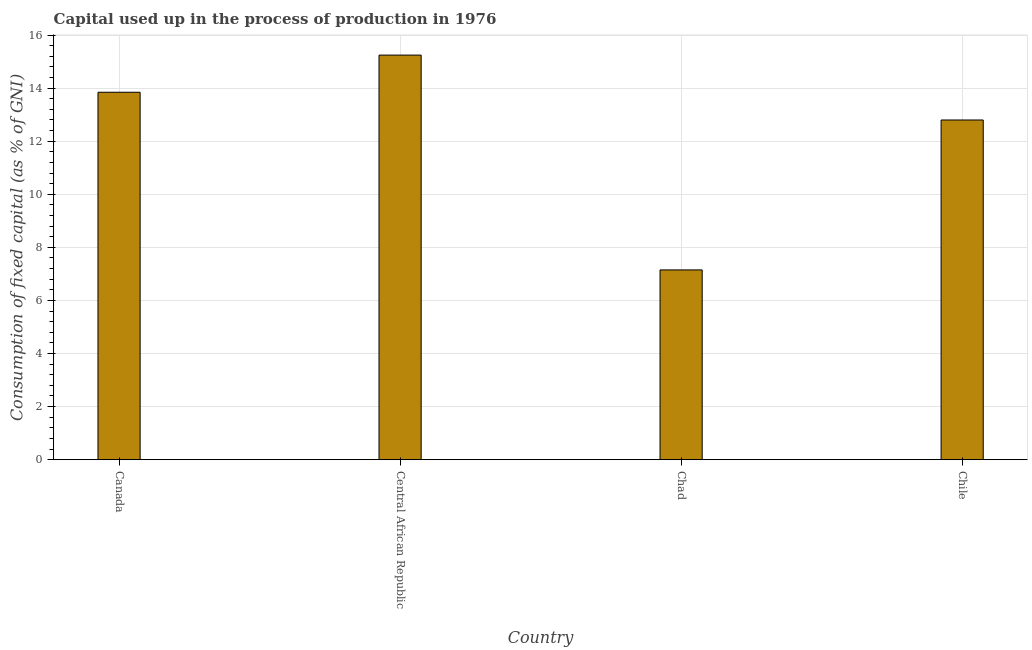What is the title of the graph?
Ensure brevity in your answer.  Capital used up in the process of production in 1976. What is the label or title of the Y-axis?
Your answer should be very brief. Consumption of fixed capital (as % of GNI). What is the consumption of fixed capital in Chile?
Ensure brevity in your answer.  12.8. Across all countries, what is the maximum consumption of fixed capital?
Offer a terse response. 15.24. Across all countries, what is the minimum consumption of fixed capital?
Offer a terse response. 7.15. In which country was the consumption of fixed capital maximum?
Your answer should be very brief. Central African Republic. In which country was the consumption of fixed capital minimum?
Provide a succinct answer. Chad. What is the sum of the consumption of fixed capital?
Give a very brief answer. 49.04. What is the difference between the consumption of fixed capital in Central African Republic and Chad?
Give a very brief answer. 8.09. What is the average consumption of fixed capital per country?
Ensure brevity in your answer.  12.26. What is the median consumption of fixed capital?
Your answer should be very brief. 13.32. What is the ratio of the consumption of fixed capital in Canada to that in Chad?
Provide a succinct answer. 1.94. Is the consumption of fixed capital in Chad less than that in Chile?
Your answer should be very brief. Yes. What is the difference between the highest and the second highest consumption of fixed capital?
Ensure brevity in your answer.  1.4. What is the difference between the highest and the lowest consumption of fixed capital?
Your answer should be very brief. 8.09. In how many countries, is the consumption of fixed capital greater than the average consumption of fixed capital taken over all countries?
Provide a succinct answer. 3. How many bars are there?
Offer a terse response. 4. What is the Consumption of fixed capital (as % of GNI) of Canada?
Offer a terse response. 13.84. What is the Consumption of fixed capital (as % of GNI) of Central African Republic?
Keep it short and to the point. 15.24. What is the Consumption of fixed capital (as % of GNI) in Chad?
Give a very brief answer. 7.15. What is the Consumption of fixed capital (as % of GNI) in Chile?
Give a very brief answer. 12.8. What is the difference between the Consumption of fixed capital (as % of GNI) in Canada and Central African Republic?
Your answer should be very brief. -1.4. What is the difference between the Consumption of fixed capital (as % of GNI) in Canada and Chad?
Your response must be concise. 6.69. What is the difference between the Consumption of fixed capital (as % of GNI) in Canada and Chile?
Keep it short and to the point. 1.05. What is the difference between the Consumption of fixed capital (as % of GNI) in Central African Republic and Chad?
Offer a terse response. 8.09. What is the difference between the Consumption of fixed capital (as % of GNI) in Central African Republic and Chile?
Keep it short and to the point. 2.44. What is the difference between the Consumption of fixed capital (as % of GNI) in Chad and Chile?
Keep it short and to the point. -5.65. What is the ratio of the Consumption of fixed capital (as % of GNI) in Canada to that in Central African Republic?
Give a very brief answer. 0.91. What is the ratio of the Consumption of fixed capital (as % of GNI) in Canada to that in Chad?
Provide a short and direct response. 1.94. What is the ratio of the Consumption of fixed capital (as % of GNI) in Canada to that in Chile?
Provide a succinct answer. 1.08. What is the ratio of the Consumption of fixed capital (as % of GNI) in Central African Republic to that in Chad?
Keep it short and to the point. 2.13. What is the ratio of the Consumption of fixed capital (as % of GNI) in Central African Republic to that in Chile?
Make the answer very short. 1.19. What is the ratio of the Consumption of fixed capital (as % of GNI) in Chad to that in Chile?
Provide a succinct answer. 0.56. 